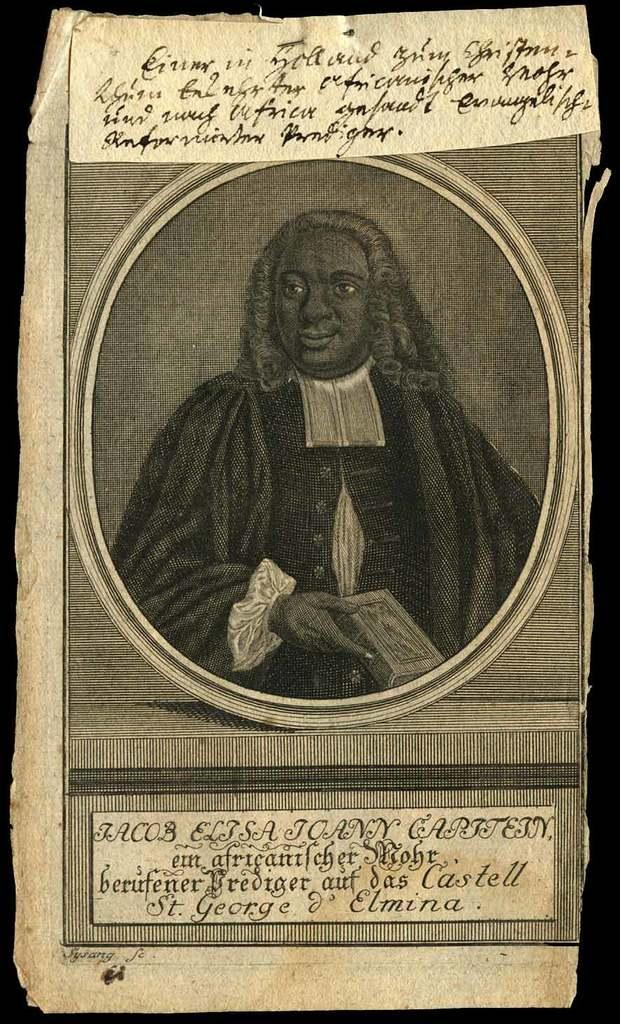What is the main subject of the image? The main subject of the image is a paper. What is depicted on the paper? The paper contains an image of a person. What is the person in the image wearing? The person in the image is wearing a coat. What can be seen at the top of the image? There is text at the top of the image. What type of jelly can be seen in the image? There is no jelly present in the image. How many boots are visible in the image? There are no boots visible in the image. 